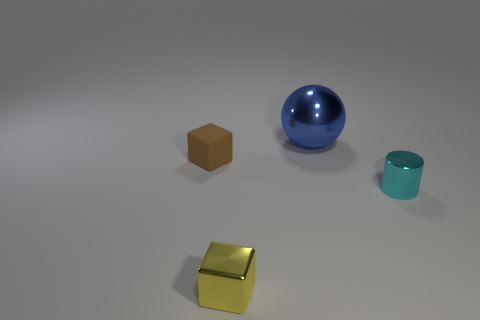Is there any other thing that has the same size as the metal sphere?
Ensure brevity in your answer.  No. What is the size of the other thing that is the same shape as the brown matte thing?
Provide a short and direct response. Small. Are there more things that are on the right side of the small brown rubber cube than blue things that are to the right of the tiny cyan thing?
Your answer should be very brief. Yes. What is the material of the tiny thing that is left of the big blue metallic object and behind the tiny shiny block?
Your answer should be very brief. Rubber. There is another small object that is the same shape as the small rubber thing; what is its color?
Your response must be concise. Yellow. What is the size of the brown cube?
Offer a terse response. Small. There is a tiny cube that is to the left of the small metallic object that is on the left side of the metallic sphere; what is its color?
Keep it short and to the point. Brown. How many shiny things are in front of the shiny cylinder and behind the small cyan metallic cylinder?
Keep it short and to the point. 0. Is the number of cyan metallic cylinders greater than the number of large cyan things?
Your response must be concise. Yes. What is the material of the big ball?
Your response must be concise. Metal. 